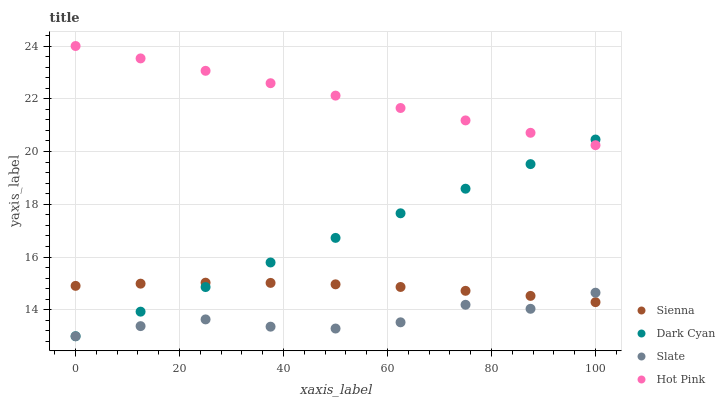Does Slate have the minimum area under the curve?
Answer yes or no. Yes. Does Hot Pink have the maximum area under the curve?
Answer yes or no. Yes. Does Dark Cyan have the minimum area under the curve?
Answer yes or no. No. Does Dark Cyan have the maximum area under the curve?
Answer yes or no. No. Is Dark Cyan the smoothest?
Answer yes or no. Yes. Is Slate the roughest?
Answer yes or no. Yes. Is Slate the smoothest?
Answer yes or no. No. Is Dark Cyan the roughest?
Answer yes or no. No. Does Dark Cyan have the lowest value?
Answer yes or no. Yes. Does Hot Pink have the lowest value?
Answer yes or no. No. Does Hot Pink have the highest value?
Answer yes or no. Yes. Does Dark Cyan have the highest value?
Answer yes or no. No. Is Sienna less than Hot Pink?
Answer yes or no. Yes. Is Hot Pink greater than Sienna?
Answer yes or no. Yes. Does Slate intersect Dark Cyan?
Answer yes or no. Yes. Is Slate less than Dark Cyan?
Answer yes or no. No. Is Slate greater than Dark Cyan?
Answer yes or no. No. Does Sienna intersect Hot Pink?
Answer yes or no. No. 